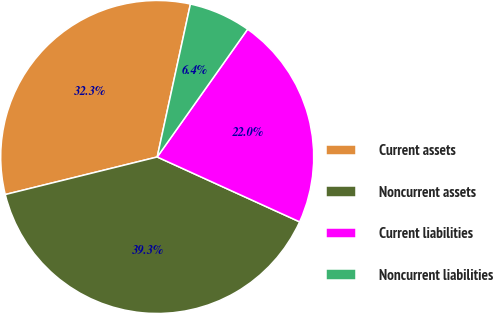<chart> <loc_0><loc_0><loc_500><loc_500><pie_chart><fcel>Current assets<fcel>Noncurrent assets<fcel>Current liabilities<fcel>Noncurrent liabilities<nl><fcel>32.26%<fcel>39.34%<fcel>22.0%<fcel>6.4%<nl></chart> 